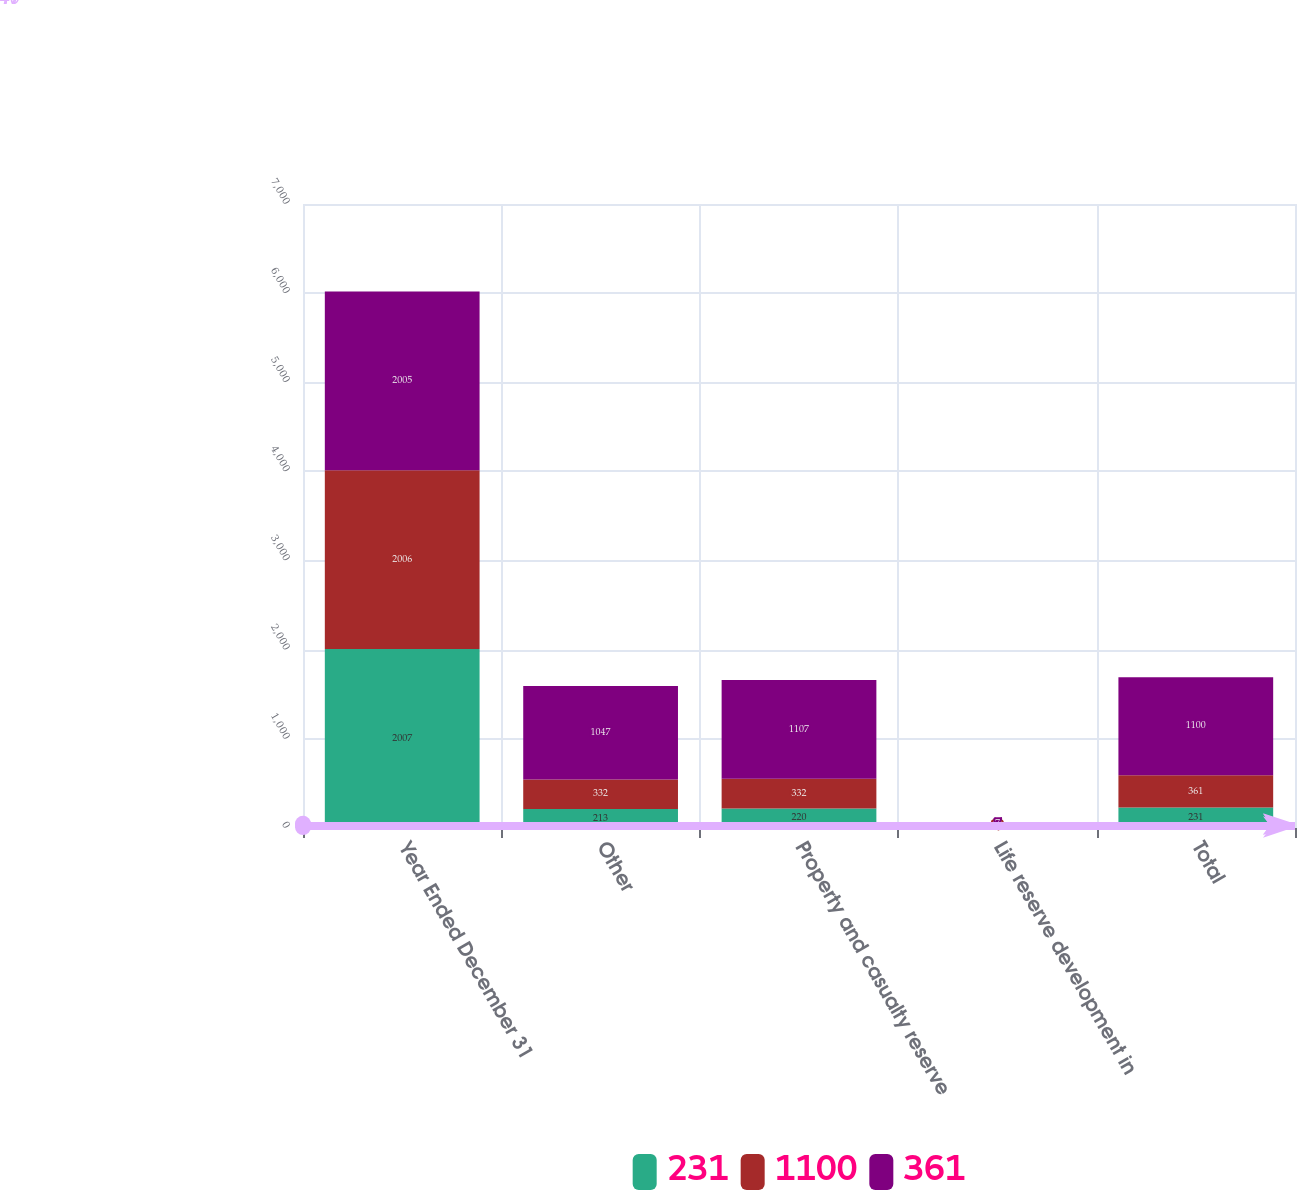Convert chart. <chart><loc_0><loc_0><loc_500><loc_500><stacked_bar_chart><ecel><fcel>Year Ended December 31<fcel>Other<fcel>Property and casualty reserve<fcel>Life reserve development in<fcel>Total<nl><fcel>231<fcel>2007<fcel>213<fcel>220<fcel>11<fcel>231<nl><fcel>1100<fcel>2006<fcel>332<fcel>332<fcel>29<fcel>361<nl><fcel>361<fcel>2005<fcel>1047<fcel>1107<fcel>7<fcel>1100<nl></chart> 